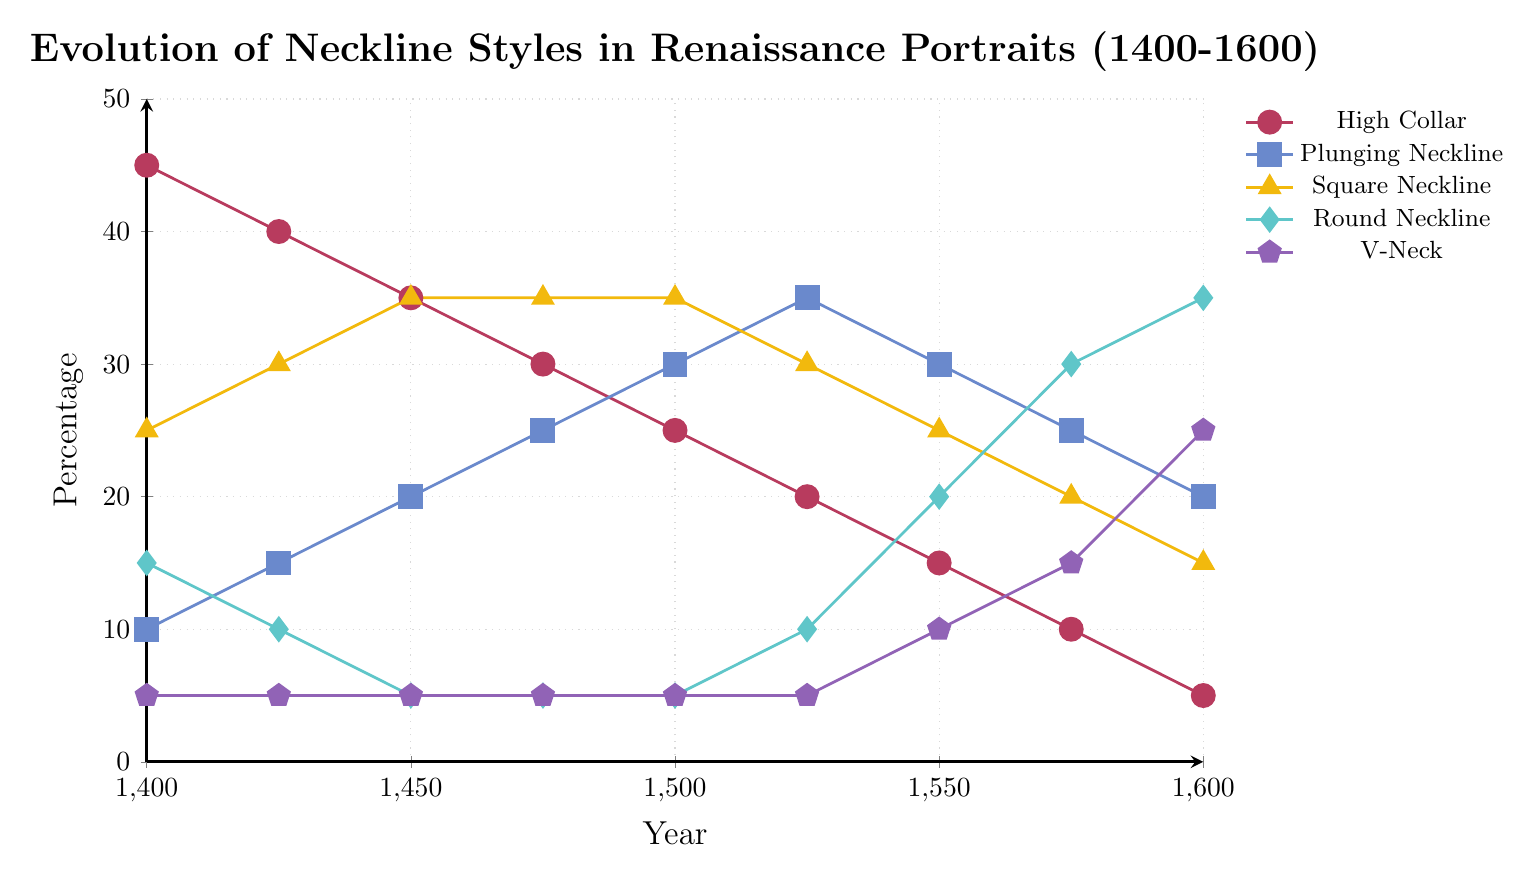What's the trend for the High Collar neckline from 1400 to 1600? The percentage of High Collar neckline styles steadily decreases from 45% in 1400 down to 5% in 1600. This is a consistent downward trend over the 200-year period.
Answer: Decreasing trend Which neckline style had the highest percentage in 1450? In 1450, Square Neckline had the highest percentage, indicated by its data point reaching 35%.
Answer: Square Neckline How does the trend of the V-Neck compare to the Round Neckline between 1500 and 1600? The V-Neck neckline has a rising trend, increasing from 5% to 25% from 1500 to 1600. Meanwhile, the Round Neckline also rises significantly from 5% to 35% during the same period. Both trends are increasing, but Round Neckline has a steeper rise.
Answer: Both trends are increasing, but Round has a steeper rise What year does the High Collar drop to equal the starting percentage of the V-Neck in 1400? The V-Neck has a percentage of 5% in 1400. The High Collar falls to 5% in 1600. Therefore, the year when High Collar drops to 5% is 1600.
Answer: 1600 What's the difference in percentage for the Square Neckline between its highest point and its lowest point? The Square Neckline reaches its highest percentage of 35% in the years 1450-1500 and its lowest percentage of 15% in 1600. The difference is 35% - 15% = 20%.
Answer: 20% Which neckline showed the least change in percentage over the 200-year period? The V-Neck shows the least fluctuation, starting at 5% in 1400 and gradually rising to 25% in 1600, a consistent and minimal change compared to other necklines.
Answer: V-Neck By how much did the Plunging Neckline increase from 1400 to 1525? The percentage of Plunging Neckline increased from 10% to 35% from 1400 to 1525. The increase is 35% - 10% = 25%.
Answer: 25% Which neckline style shows a direct correlation with the decrease in High Collar over the years? The Round Neckline exhibits a direct negative correlation with the High Collar. As the High Collar decreases from 45% to 5%, the Round Neckline increases from 15% to 35%, especially noticeable from 1400 to 1600.
Answer: Round Neckline At what year do the percentages for Square Neckline and Round Neckline meet exactly? The Square and Round Necklines do not meet exactly at the same percentage in the given data set; their trends are always different.
Answer: Never What is the combined percentage of all neckline styles in 1550? Summing up the percentages of all neckline styles in 1550, we get 15% (High Collar) + 30% (Plunging Neckline) + 25% (Square Neckline) + 20% (Round Neckline) + 10% (V-Neck) = 100%.
Answer: 100% 